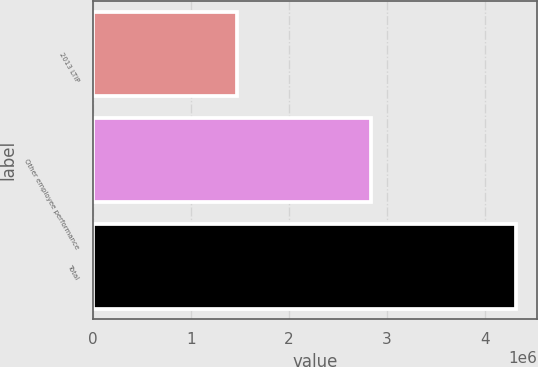<chart> <loc_0><loc_0><loc_500><loc_500><bar_chart><fcel>2013 LTIP<fcel>Other employee performance<fcel>Total<nl><fcel>1.472e+06<fcel>2.84e+06<fcel>4.312e+06<nl></chart> 